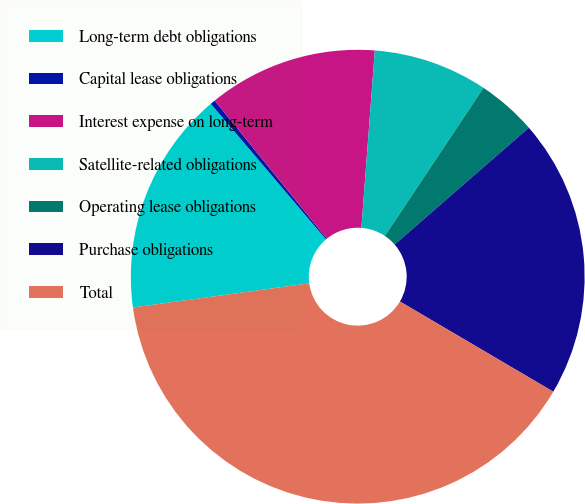Convert chart to OTSL. <chart><loc_0><loc_0><loc_500><loc_500><pie_chart><fcel>Long-term debt obligations<fcel>Capital lease obligations<fcel>Interest expense on long-term<fcel>Satellite-related obligations<fcel>Operating lease obligations<fcel>Purchase obligations<fcel>Total<nl><fcel>15.96%<fcel>0.35%<fcel>12.06%<fcel>8.15%<fcel>4.25%<fcel>19.86%<fcel>39.37%<nl></chart> 